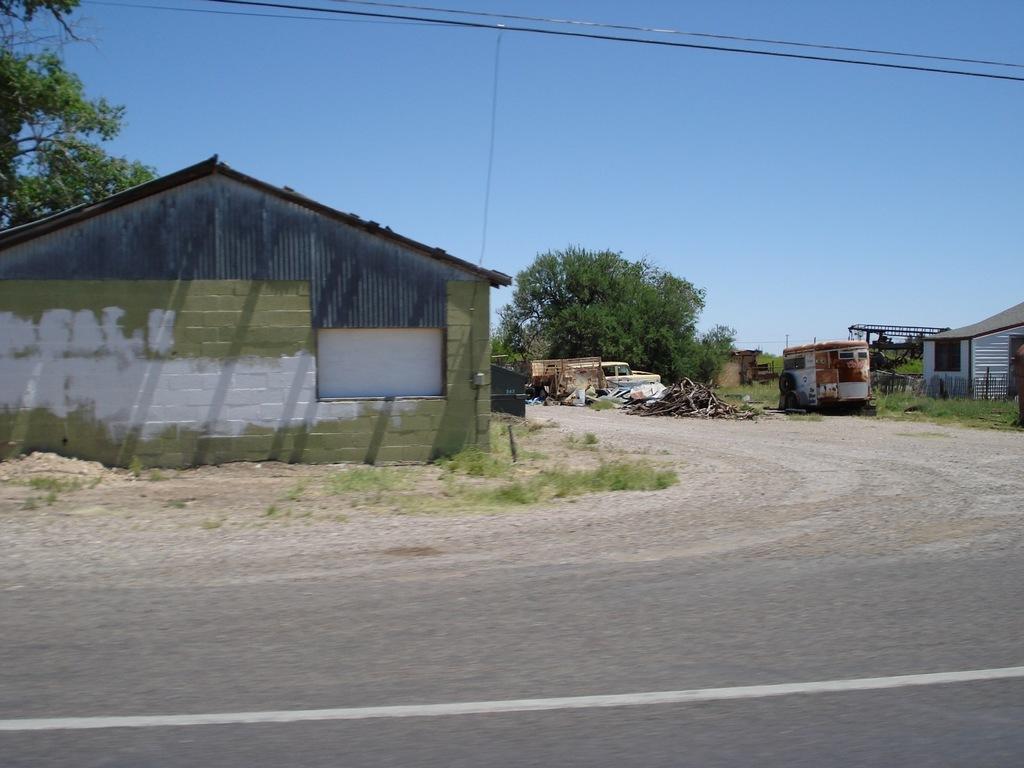Describe this image in one or two sentences. In this image, I can the sheds, a vehicle and scrap items. There are trees and grass. At the bottom of the image, I can see the road. At the top of the image, I can see the wires. In the background, there is the sky. 